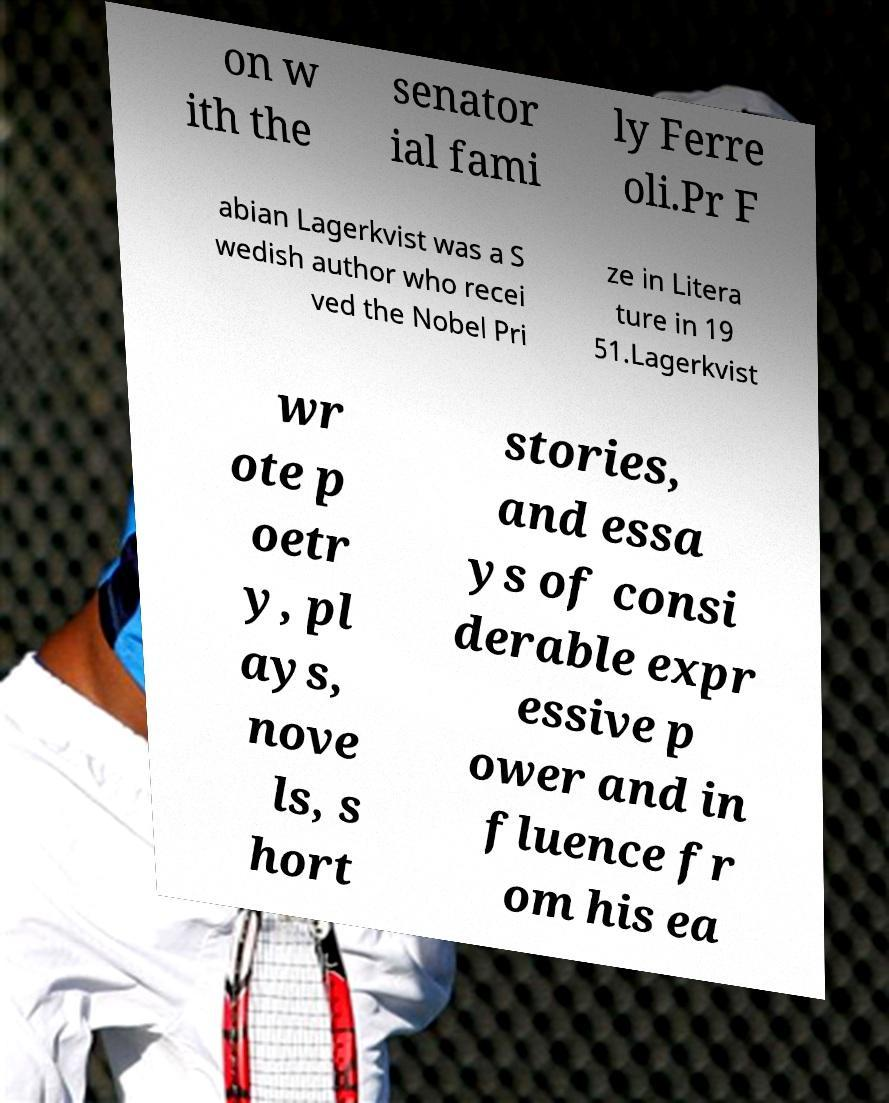For documentation purposes, I need the text within this image transcribed. Could you provide that? on w ith the senator ial fami ly Ferre oli.Pr F abian Lagerkvist was a S wedish author who recei ved the Nobel Pri ze in Litera ture in 19 51.Lagerkvist wr ote p oetr y, pl ays, nove ls, s hort stories, and essa ys of consi derable expr essive p ower and in fluence fr om his ea 